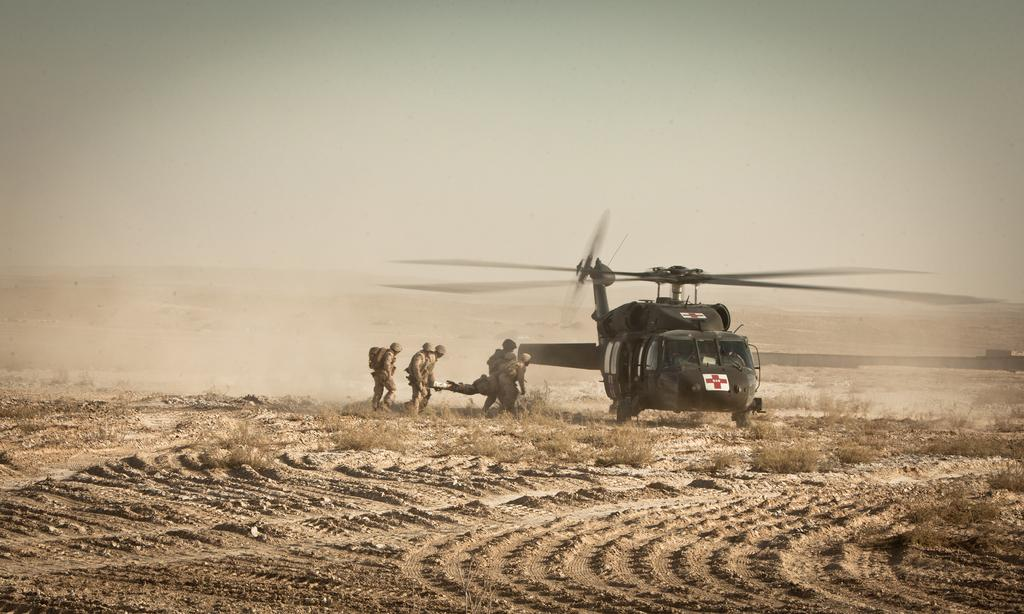What is the main subject of the picture? The main subject of the picture is a plane. Can you describe the color of the plane? The plane is black in color. What else can be seen in the picture besides the plane? There are people around the plane and sand and stones on the floor. What type of bait is being used to catch fish in the picture? There is no fishing or bait present in the image; it features a black plane with people around it and sand and stones on the floor. Can you tell me where the brother is in the picture? There is no mention of a brother or any specific person in the image; it only shows a black plane, people, and the floor. 